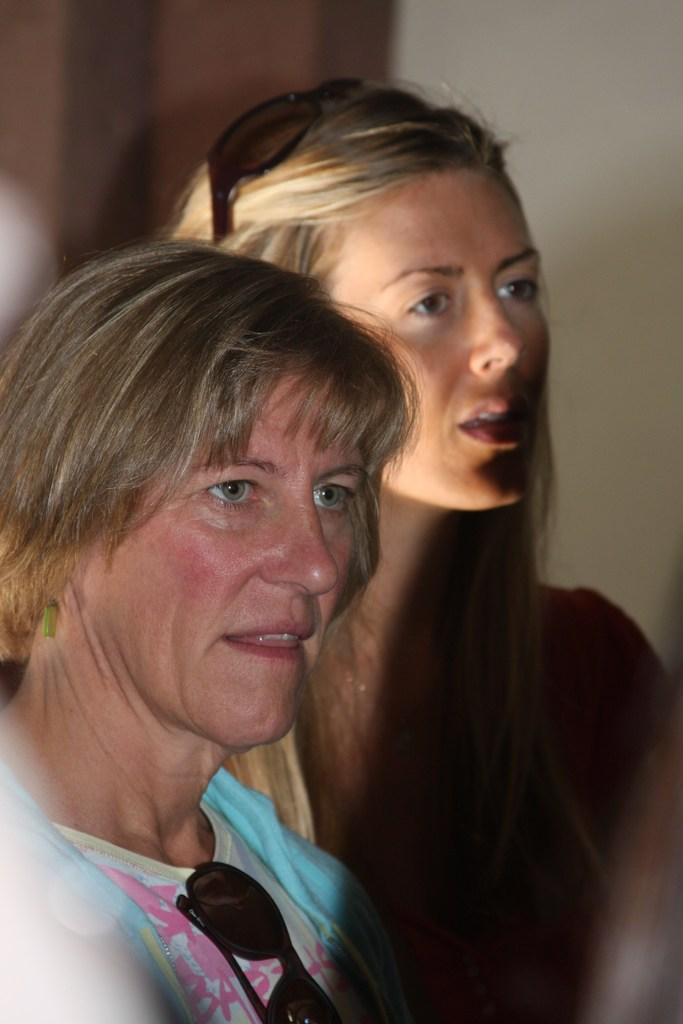How would you summarize this image in a sentence or two? In the center of the image we can see ladies. In the background there is a wall. 